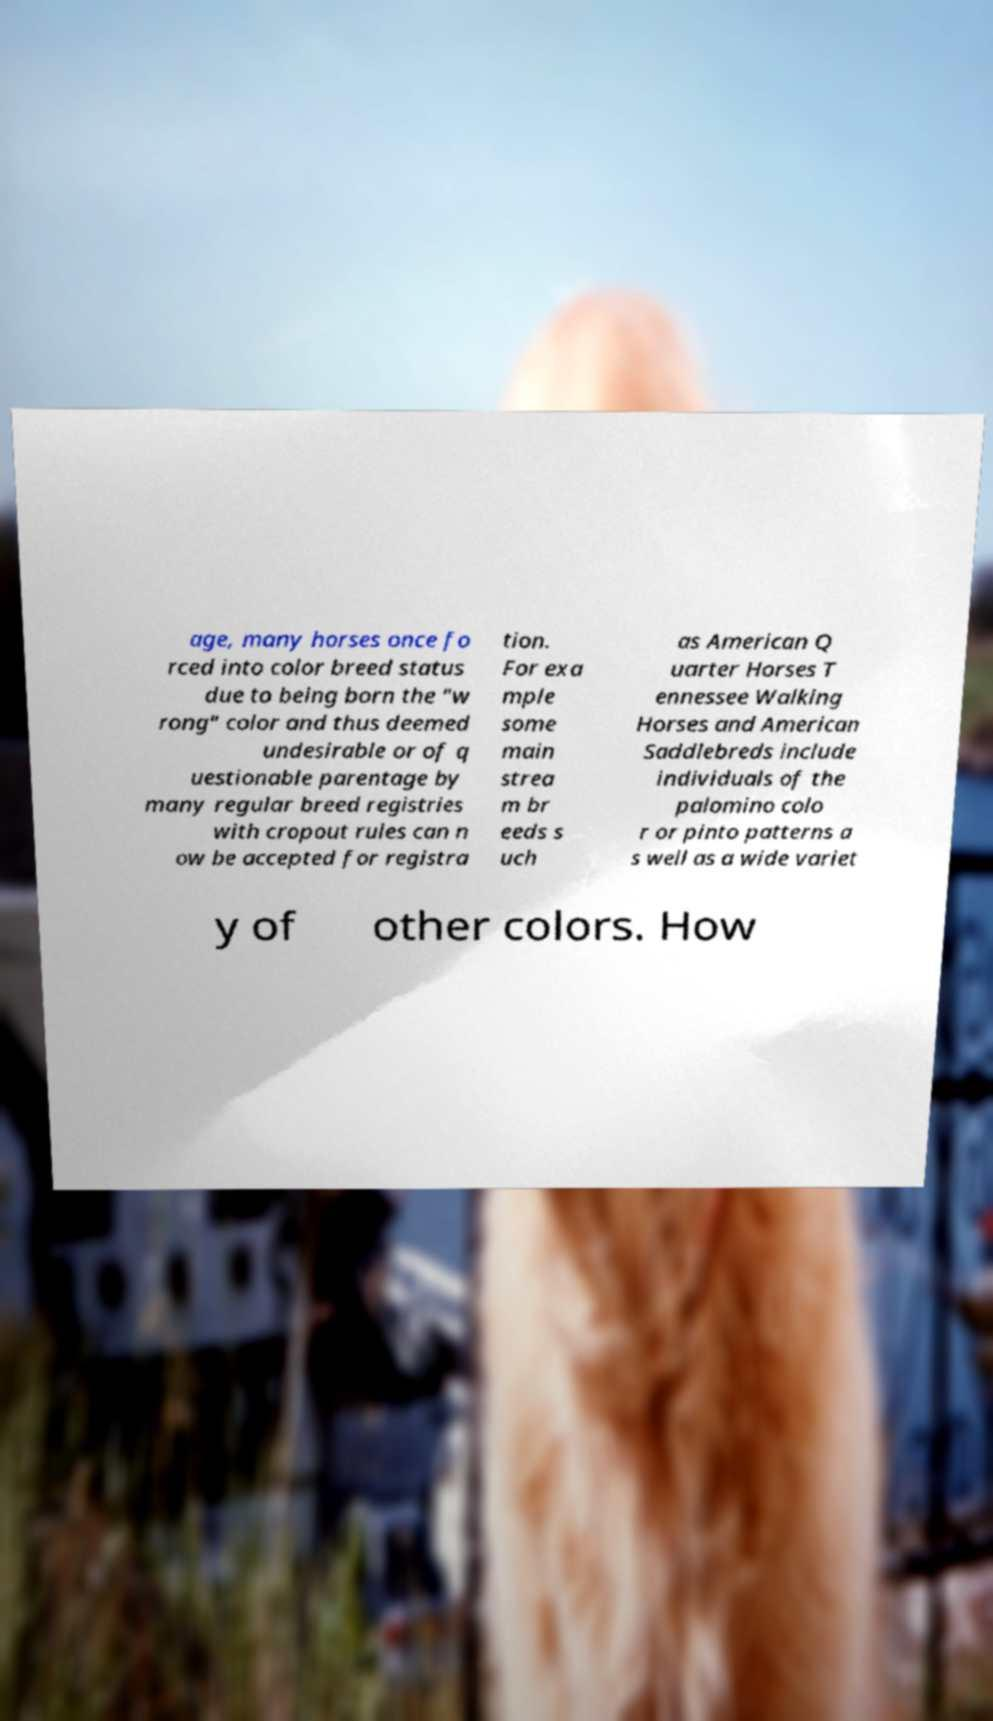There's text embedded in this image that I need extracted. Can you transcribe it verbatim? age, many horses once fo rced into color breed status due to being born the "w rong" color and thus deemed undesirable or of q uestionable parentage by many regular breed registries with cropout rules can n ow be accepted for registra tion. For exa mple some main strea m br eeds s uch as American Q uarter Horses T ennessee Walking Horses and American Saddlebreds include individuals of the palomino colo r or pinto patterns a s well as a wide variet y of other colors. How 